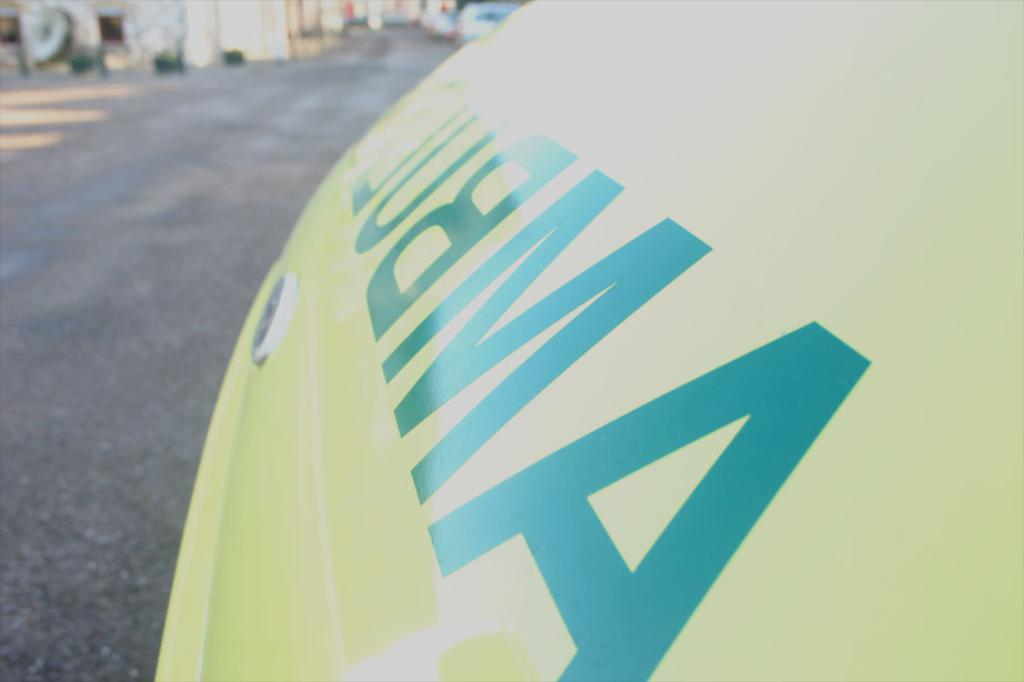What is the main object in the image? There is a fuel tank in the image. Is there any text on the fuel tank? Yes, the word "AMBUL" is written on the fuel tank. How many servants are attending to the clam in the image? There are no servants or clams present in the image; it features a fuel tank with the word "AMBUL" written on it. 